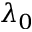<formula> <loc_0><loc_0><loc_500><loc_500>\lambda _ { 0 }</formula> 